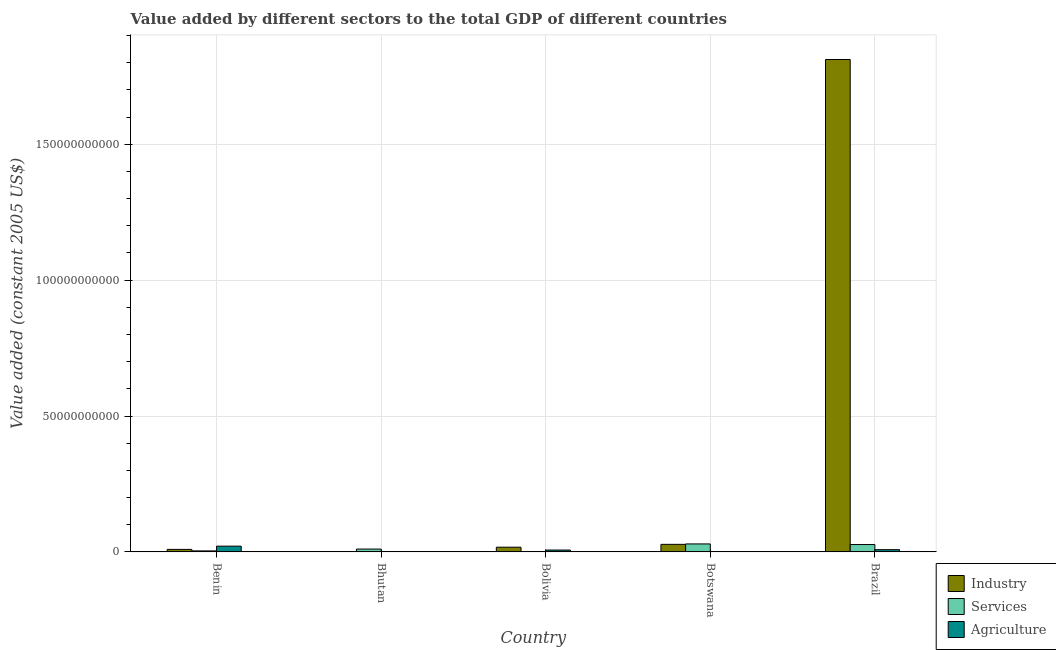How many different coloured bars are there?
Your answer should be compact. 3. How many groups of bars are there?
Your answer should be compact. 5. Are the number of bars on each tick of the X-axis equal?
Your answer should be compact. Yes. How many bars are there on the 5th tick from the right?
Your answer should be very brief. 3. What is the value added by agricultural sector in Bhutan?
Your answer should be very brief. 6.53e+07. Across all countries, what is the maximum value added by services?
Your answer should be very brief. 2.94e+09. Across all countries, what is the minimum value added by industrial sector?
Keep it short and to the point. 1.25e+08. In which country was the value added by industrial sector minimum?
Your answer should be compact. Bhutan. What is the total value added by agricultural sector in the graph?
Provide a short and direct response. 3.83e+09. What is the difference between the value added by agricultural sector in Bhutan and that in Brazil?
Offer a very short reply. -7.60e+08. What is the difference between the value added by industrial sector in Bolivia and the value added by agricultural sector in Bhutan?
Give a very brief answer. 1.67e+09. What is the average value added by agricultural sector per country?
Provide a short and direct response. 7.67e+08. What is the difference between the value added by agricultural sector and value added by industrial sector in Bhutan?
Ensure brevity in your answer.  -5.97e+07. In how many countries, is the value added by agricultural sector greater than 40000000000 US$?
Your answer should be compact. 0. What is the ratio of the value added by agricultural sector in Benin to that in Bhutan?
Give a very brief answer. 32.41. Is the value added by industrial sector in Benin less than that in Botswana?
Your response must be concise. Yes. Is the difference between the value added by agricultural sector in Benin and Bolivia greater than the difference between the value added by services in Benin and Bolivia?
Your response must be concise. Yes. What is the difference between the highest and the second highest value added by industrial sector?
Provide a succinct answer. 1.78e+11. What is the difference between the highest and the lowest value added by industrial sector?
Make the answer very short. 1.81e+11. Is the sum of the value added by agricultural sector in Bhutan and Brazil greater than the maximum value added by industrial sector across all countries?
Offer a very short reply. No. What does the 1st bar from the left in Bhutan represents?
Your answer should be compact. Industry. What does the 3rd bar from the right in Botswana represents?
Make the answer very short. Industry. How many countries are there in the graph?
Keep it short and to the point. 5. Are the values on the major ticks of Y-axis written in scientific E-notation?
Your response must be concise. No. Does the graph contain grids?
Keep it short and to the point. Yes. How many legend labels are there?
Offer a terse response. 3. What is the title of the graph?
Offer a terse response. Value added by different sectors to the total GDP of different countries. What is the label or title of the Y-axis?
Make the answer very short. Value added (constant 2005 US$). What is the Value added (constant 2005 US$) of Industry in Benin?
Offer a very short reply. 9.25e+08. What is the Value added (constant 2005 US$) of Services in Benin?
Your answer should be compact. 3.76e+08. What is the Value added (constant 2005 US$) of Agriculture in Benin?
Keep it short and to the point. 2.12e+09. What is the Value added (constant 2005 US$) in Industry in Bhutan?
Offer a very short reply. 1.25e+08. What is the Value added (constant 2005 US$) of Services in Bhutan?
Provide a short and direct response. 1.05e+09. What is the Value added (constant 2005 US$) in Agriculture in Bhutan?
Your response must be concise. 6.53e+07. What is the Value added (constant 2005 US$) in Industry in Bolivia?
Provide a short and direct response. 1.74e+09. What is the Value added (constant 2005 US$) of Services in Bolivia?
Keep it short and to the point. 1.12e+08. What is the Value added (constant 2005 US$) of Agriculture in Bolivia?
Offer a terse response. 6.89e+08. What is the Value added (constant 2005 US$) in Industry in Botswana?
Provide a short and direct response. 2.78e+09. What is the Value added (constant 2005 US$) of Services in Botswana?
Your answer should be very brief. 2.94e+09. What is the Value added (constant 2005 US$) of Agriculture in Botswana?
Your answer should be compact. 1.35e+08. What is the Value added (constant 2005 US$) of Industry in Brazil?
Your answer should be very brief. 1.81e+11. What is the Value added (constant 2005 US$) of Services in Brazil?
Your response must be concise. 2.71e+09. What is the Value added (constant 2005 US$) of Agriculture in Brazil?
Your response must be concise. 8.26e+08. Across all countries, what is the maximum Value added (constant 2005 US$) in Industry?
Offer a very short reply. 1.81e+11. Across all countries, what is the maximum Value added (constant 2005 US$) in Services?
Your answer should be compact. 2.94e+09. Across all countries, what is the maximum Value added (constant 2005 US$) of Agriculture?
Keep it short and to the point. 2.12e+09. Across all countries, what is the minimum Value added (constant 2005 US$) in Industry?
Your answer should be very brief. 1.25e+08. Across all countries, what is the minimum Value added (constant 2005 US$) in Services?
Offer a terse response. 1.12e+08. Across all countries, what is the minimum Value added (constant 2005 US$) in Agriculture?
Provide a succinct answer. 6.53e+07. What is the total Value added (constant 2005 US$) in Industry in the graph?
Keep it short and to the point. 1.87e+11. What is the total Value added (constant 2005 US$) in Services in the graph?
Your answer should be very brief. 7.19e+09. What is the total Value added (constant 2005 US$) of Agriculture in the graph?
Your answer should be very brief. 3.83e+09. What is the difference between the Value added (constant 2005 US$) in Industry in Benin and that in Bhutan?
Your answer should be compact. 7.99e+08. What is the difference between the Value added (constant 2005 US$) of Services in Benin and that in Bhutan?
Provide a short and direct response. -6.75e+08. What is the difference between the Value added (constant 2005 US$) in Agriculture in Benin and that in Bhutan?
Ensure brevity in your answer.  2.05e+09. What is the difference between the Value added (constant 2005 US$) in Industry in Benin and that in Bolivia?
Ensure brevity in your answer.  -8.11e+08. What is the difference between the Value added (constant 2005 US$) in Services in Benin and that in Bolivia?
Make the answer very short. 2.64e+08. What is the difference between the Value added (constant 2005 US$) in Agriculture in Benin and that in Bolivia?
Your answer should be very brief. 1.43e+09. What is the difference between the Value added (constant 2005 US$) in Industry in Benin and that in Botswana?
Keep it short and to the point. -1.85e+09. What is the difference between the Value added (constant 2005 US$) of Services in Benin and that in Botswana?
Your answer should be very brief. -2.56e+09. What is the difference between the Value added (constant 2005 US$) of Agriculture in Benin and that in Botswana?
Provide a short and direct response. 1.98e+09. What is the difference between the Value added (constant 2005 US$) of Industry in Benin and that in Brazil?
Keep it short and to the point. -1.80e+11. What is the difference between the Value added (constant 2005 US$) in Services in Benin and that in Brazil?
Your answer should be very brief. -2.34e+09. What is the difference between the Value added (constant 2005 US$) in Agriculture in Benin and that in Brazil?
Keep it short and to the point. 1.29e+09. What is the difference between the Value added (constant 2005 US$) of Industry in Bhutan and that in Bolivia?
Your answer should be compact. -1.61e+09. What is the difference between the Value added (constant 2005 US$) of Services in Bhutan and that in Bolivia?
Provide a short and direct response. 9.39e+08. What is the difference between the Value added (constant 2005 US$) in Agriculture in Bhutan and that in Bolivia?
Your answer should be compact. -6.24e+08. What is the difference between the Value added (constant 2005 US$) in Industry in Bhutan and that in Botswana?
Offer a very short reply. -2.65e+09. What is the difference between the Value added (constant 2005 US$) of Services in Bhutan and that in Botswana?
Your response must be concise. -1.89e+09. What is the difference between the Value added (constant 2005 US$) of Agriculture in Bhutan and that in Botswana?
Ensure brevity in your answer.  -7.01e+07. What is the difference between the Value added (constant 2005 US$) of Industry in Bhutan and that in Brazil?
Keep it short and to the point. -1.81e+11. What is the difference between the Value added (constant 2005 US$) in Services in Bhutan and that in Brazil?
Make the answer very short. -1.66e+09. What is the difference between the Value added (constant 2005 US$) of Agriculture in Bhutan and that in Brazil?
Provide a succinct answer. -7.60e+08. What is the difference between the Value added (constant 2005 US$) in Industry in Bolivia and that in Botswana?
Keep it short and to the point. -1.04e+09. What is the difference between the Value added (constant 2005 US$) of Services in Bolivia and that in Botswana?
Keep it short and to the point. -2.83e+09. What is the difference between the Value added (constant 2005 US$) in Agriculture in Bolivia and that in Botswana?
Provide a short and direct response. 5.54e+08. What is the difference between the Value added (constant 2005 US$) of Industry in Bolivia and that in Brazil?
Your answer should be compact. -1.79e+11. What is the difference between the Value added (constant 2005 US$) of Services in Bolivia and that in Brazil?
Offer a very short reply. -2.60e+09. What is the difference between the Value added (constant 2005 US$) of Agriculture in Bolivia and that in Brazil?
Your answer should be compact. -1.37e+08. What is the difference between the Value added (constant 2005 US$) in Industry in Botswana and that in Brazil?
Provide a succinct answer. -1.78e+11. What is the difference between the Value added (constant 2005 US$) of Services in Botswana and that in Brazil?
Provide a short and direct response. 2.26e+08. What is the difference between the Value added (constant 2005 US$) in Agriculture in Botswana and that in Brazil?
Your answer should be very brief. -6.90e+08. What is the difference between the Value added (constant 2005 US$) in Industry in Benin and the Value added (constant 2005 US$) in Services in Bhutan?
Your answer should be compact. -1.26e+08. What is the difference between the Value added (constant 2005 US$) of Industry in Benin and the Value added (constant 2005 US$) of Agriculture in Bhutan?
Your answer should be very brief. 8.59e+08. What is the difference between the Value added (constant 2005 US$) in Services in Benin and the Value added (constant 2005 US$) in Agriculture in Bhutan?
Ensure brevity in your answer.  3.10e+08. What is the difference between the Value added (constant 2005 US$) of Industry in Benin and the Value added (constant 2005 US$) of Services in Bolivia?
Provide a succinct answer. 8.13e+08. What is the difference between the Value added (constant 2005 US$) in Industry in Benin and the Value added (constant 2005 US$) in Agriculture in Bolivia?
Give a very brief answer. 2.35e+08. What is the difference between the Value added (constant 2005 US$) of Services in Benin and the Value added (constant 2005 US$) of Agriculture in Bolivia?
Provide a succinct answer. -3.13e+08. What is the difference between the Value added (constant 2005 US$) of Industry in Benin and the Value added (constant 2005 US$) of Services in Botswana?
Give a very brief answer. -2.01e+09. What is the difference between the Value added (constant 2005 US$) in Industry in Benin and the Value added (constant 2005 US$) in Agriculture in Botswana?
Your answer should be very brief. 7.89e+08. What is the difference between the Value added (constant 2005 US$) of Services in Benin and the Value added (constant 2005 US$) of Agriculture in Botswana?
Ensure brevity in your answer.  2.40e+08. What is the difference between the Value added (constant 2005 US$) in Industry in Benin and the Value added (constant 2005 US$) in Services in Brazil?
Offer a very short reply. -1.79e+09. What is the difference between the Value added (constant 2005 US$) of Industry in Benin and the Value added (constant 2005 US$) of Agriculture in Brazil?
Your response must be concise. 9.87e+07. What is the difference between the Value added (constant 2005 US$) of Services in Benin and the Value added (constant 2005 US$) of Agriculture in Brazil?
Ensure brevity in your answer.  -4.50e+08. What is the difference between the Value added (constant 2005 US$) in Industry in Bhutan and the Value added (constant 2005 US$) in Services in Bolivia?
Give a very brief answer. 1.33e+07. What is the difference between the Value added (constant 2005 US$) of Industry in Bhutan and the Value added (constant 2005 US$) of Agriculture in Bolivia?
Offer a very short reply. -5.64e+08. What is the difference between the Value added (constant 2005 US$) in Services in Bhutan and the Value added (constant 2005 US$) in Agriculture in Bolivia?
Provide a short and direct response. 3.61e+08. What is the difference between the Value added (constant 2005 US$) in Industry in Bhutan and the Value added (constant 2005 US$) in Services in Botswana?
Your response must be concise. -2.81e+09. What is the difference between the Value added (constant 2005 US$) in Industry in Bhutan and the Value added (constant 2005 US$) in Agriculture in Botswana?
Provide a short and direct response. -1.04e+07. What is the difference between the Value added (constant 2005 US$) in Services in Bhutan and the Value added (constant 2005 US$) in Agriculture in Botswana?
Provide a succinct answer. 9.15e+08. What is the difference between the Value added (constant 2005 US$) in Industry in Bhutan and the Value added (constant 2005 US$) in Services in Brazil?
Keep it short and to the point. -2.59e+09. What is the difference between the Value added (constant 2005 US$) in Industry in Bhutan and the Value added (constant 2005 US$) in Agriculture in Brazil?
Offer a terse response. -7.01e+08. What is the difference between the Value added (constant 2005 US$) of Services in Bhutan and the Value added (constant 2005 US$) of Agriculture in Brazil?
Keep it short and to the point. 2.25e+08. What is the difference between the Value added (constant 2005 US$) of Industry in Bolivia and the Value added (constant 2005 US$) of Services in Botswana?
Keep it short and to the point. -1.20e+09. What is the difference between the Value added (constant 2005 US$) of Industry in Bolivia and the Value added (constant 2005 US$) of Agriculture in Botswana?
Ensure brevity in your answer.  1.60e+09. What is the difference between the Value added (constant 2005 US$) in Services in Bolivia and the Value added (constant 2005 US$) in Agriculture in Botswana?
Provide a succinct answer. -2.37e+07. What is the difference between the Value added (constant 2005 US$) in Industry in Bolivia and the Value added (constant 2005 US$) in Services in Brazil?
Provide a short and direct response. -9.76e+08. What is the difference between the Value added (constant 2005 US$) in Industry in Bolivia and the Value added (constant 2005 US$) in Agriculture in Brazil?
Give a very brief answer. 9.10e+08. What is the difference between the Value added (constant 2005 US$) of Services in Bolivia and the Value added (constant 2005 US$) of Agriculture in Brazil?
Your response must be concise. -7.14e+08. What is the difference between the Value added (constant 2005 US$) of Industry in Botswana and the Value added (constant 2005 US$) of Services in Brazil?
Offer a very short reply. 6.63e+07. What is the difference between the Value added (constant 2005 US$) in Industry in Botswana and the Value added (constant 2005 US$) in Agriculture in Brazil?
Give a very brief answer. 1.95e+09. What is the difference between the Value added (constant 2005 US$) of Services in Botswana and the Value added (constant 2005 US$) of Agriculture in Brazil?
Offer a very short reply. 2.11e+09. What is the average Value added (constant 2005 US$) in Industry per country?
Your answer should be compact. 3.73e+1. What is the average Value added (constant 2005 US$) of Services per country?
Keep it short and to the point. 1.44e+09. What is the average Value added (constant 2005 US$) of Agriculture per country?
Make the answer very short. 7.67e+08. What is the difference between the Value added (constant 2005 US$) of Industry and Value added (constant 2005 US$) of Services in Benin?
Offer a very short reply. 5.49e+08. What is the difference between the Value added (constant 2005 US$) of Industry and Value added (constant 2005 US$) of Agriculture in Benin?
Provide a succinct answer. -1.19e+09. What is the difference between the Value added (constant 2005 US$) of Services and Value added (constant 2005 US$) of Agriculture in Benin?
Offer a terse response. -1.74e+09. What is the difference between the Value added (constant 2005 US$) in Industry and Value added (constant 2005 US$) in Services in Bhutan?
Give a very brief answer. -9.25e+08. What is the difference between the Value added (constant 2005 US$) in Industry and Value added (constant 2005 US$) in Agriculture in Bhutan?
Your response must be concise. 5.97e+07. What is the difference between the Value added (constant 2005 US$) of Services and Value added (constant 2005 US$) of Agriculture in Bhutan?
Offer a terse response. 9.85e+08. What is the difference between the Value added (constant 2005 US$) of Industry and Value added (constant 2005 US$) of Services in Bolivia?
Offer a terse response. 1.62e+09. What is the difference between the Value added (constant 2005 US$) in Industry and Value added (constant 2005 US$) in Agriculture in Bolivia?
Provide a short and direct response. 1.05e+09. What is the difference between the Value added (constant 2005 US$) of Services and Value added (constant 2005 US$) of Agriculture in Bolivia?
Your answer should be very brief. -5.77e+08. What is the difference between the Value added (constant 2005 US$) in Industry and Value added (constant 2005 US$) in Services in Botswana?
Your answer should be very brief. -1.60e+08. What is the difference between the Value added (constant 2005 US$) in Industry and Value added (constant 2005 US$) in Agriculture in Botswana?
Your answer should be compact. 2.64e+09. What is the difference between the Value added (constant 2005 US$) of Services and Value added (constant 2005 US$) of Agriculture in Botswana?
Provide a short and direct response. 2.80e+09. What is the difference between the Value added (constant 2005 US$) in Industry and Value added (constant 2005 US$) in Services in Brazil?
Provide a succinct answer. 1.78e+11. What is the difference between the Value added (constant 2005 US$) of Industry and Value added (constant 2005 US$) of Agriculture in Brazil?
Offer a very short reply. 1.80e+11. What is the difference between the Value added (constant 2005 US$) of Services and Value added (constant 2005 US$) of Agriculture in Brazil?
Your answer should be very brief. 1.89e+09. What is the ratio of the Value added (constant 2005 US$) in Industry in Benin to that in Bhutan?
Offer a terse response. 7.39. What is the ratio of the Value added (constant 2005 US$) in Services in Benin to that in Bhutan?
Keep it short and to the point. 0.36. What is the ratio of the Value added (constant 2005 US$) in Agriculture in Benin to that in Bhutan?
Provide a succinct answer. 32.41. What is the ratio of the Value added (constant 2005 US$) of Industry in Benin to that in Bolivia?
Keep it short and to the point. 0.53. What is the ratio of the Value added (constant 2005 US$) of Services in Benin to that in Bolivia?
Offer a very short reply. 3.36. What is the ratio of the Value added (constant 2005 US$) of Agriculture in Benin to that in Bolivia?
Your answer should be very brief. 3.07. What is the ratio of the Value added (constant 2005 US$) in Industry in Benin to that in Botswana?
Offer a very short reply. 0.33. What is the ratio of the Value added (constant 2005 US$) of Services in Benin to that in Botswana?
Keep it short and to the point. 0.13. What is the ratio of the Value added (constant 2005 US$) in Agriculture in Benin to that in Botswana?
Provide a succinct answer. 15.63. What is the ratio of the Value added (constant 2005 US$) of Industry in Benin to that in Brazil?
Your answer should be very brief. 0.01. What is the ratio of the Value added (constant 2005 US$) of Services in Benin to that in Brazil?
Keep it short and to the point. 0.14. What is the ratio of the Value added (constant 2005 US$) of Agriculture in Benin to that in Brazil?
Provide a short and direct response. 2.56. What is the ratio of the Value added (constant 2005 US$) in Industry in Bhutan to that in Bolivia?
Your answer should be compact. 0.07. What is the ratio of the Value added (constant 2005 US$) of Services in Bhutan to that in Bolivia?
Your response must be concise. 9.39. What is the ratio of the Value added (constant 2005 US$) of Agriculture in Bhutan to that in Bolivia?
Provide a succinct answer. 0.09. What is the ratio of the Value added (constant 2005 US$) of Industry in Bhutan to that in Botswana?
Provide a short and direct response. 0.04. What is the ratio of the Value added (constant 2005 US$) in Services in Bhutan to that in Botswana?
Give a very brief answer. 0.36. What is the ratio of the Value added (constant 2005 US$) in Agriculture in Bhutan to that in Botswana?
Your answer should be very brief. 0.48. What is the ratio of the Value added (constant 2005 US$) of Industry in Bhutan to that in Brazil?
Your answer should be very brief. 0. What is the ratio of the Value added (constant 2005 US$) of Services in Bhutan to that in Brazil?
Ensure brevity in your answer.  0.39. What is the ratio of the Value added (constant 2005 US$) of Agriculture in Bhutan to that in Brazil?
Your answer should be compact. 0.08. What is the ratio of the Value added (constant 2005 US$) in Industry in Bolivia to that in Botswana?
Offer a terse response. 0.62. What is the ratio of the Value added (constant 2005 US$) in Services in Bolivia to that in Botswana?
Provide a succinct answer. 0.04. What is the ratio of the Value added (constant 2005 US$) of Agriculture in Bolivia to that in Botswana?
Your answer should be very brief. 5.09. What is the ratio of the Value added (constant 2005 US$) of Industry in Bolivia to that in Brazil?
Provide a succinct answer. 0.01. What is the ratio of the Value added (constant 2005 US$) of Services in Bolivia to that in Brazil?
Ensure brevity in your answer.  0.04. What is the ratio of the Value added (constant 2005 US$) in Agriculture in Bolivia to that in Brazil?
Your response must be concise. 0.83. What is the ratio of the Value added (constant 2005 US$) of Industry in Botswana to that in Brazil?
Your answer should be very brief. 0.02. What is the ratio of the Value added (constant 2005 US$) in Services in Botswana to that in Brazil?
Your response must be concise. 1.08. What is the ratio of the Value added (constant 2005 US$) in Agriculture in Botswana to that in Brazil?
Make the answer very short. 0.16. What is the difference between the highest and the second highest Value added (constant 2005 US$) in Industry?
Give a very brief answer. 1.78e+11. What is the difference between the highest and the second highest Value added (constant 2005 US$) of Services?
Offer a very short reply. 2.26e+08. What is the difference between the highest and the second highest Value added (constant 2005 US$) of Agriculture?
Provide a short and direct response. 1.29e+09. What is the difference between the highest and the lowest Value added (constant 2005 US$) in Industry?
Offer a terse response. 1.81e+11. What is the difference between the highest and the lowest Value added (constant 2005 US$) in Services?
Provide a short and direct response. 2.83e+09. What is the difference between the highest and the lowest Value added (constant 2005 US$) of Agriculture?
Make the answer very short. 2.05e+09. 